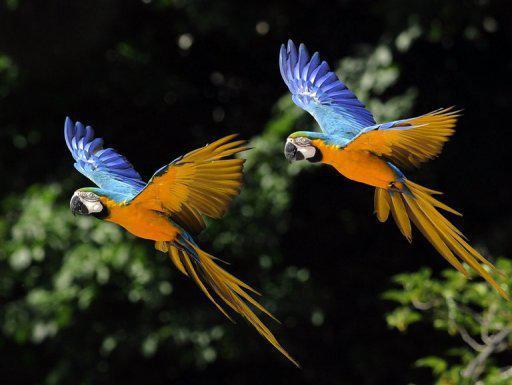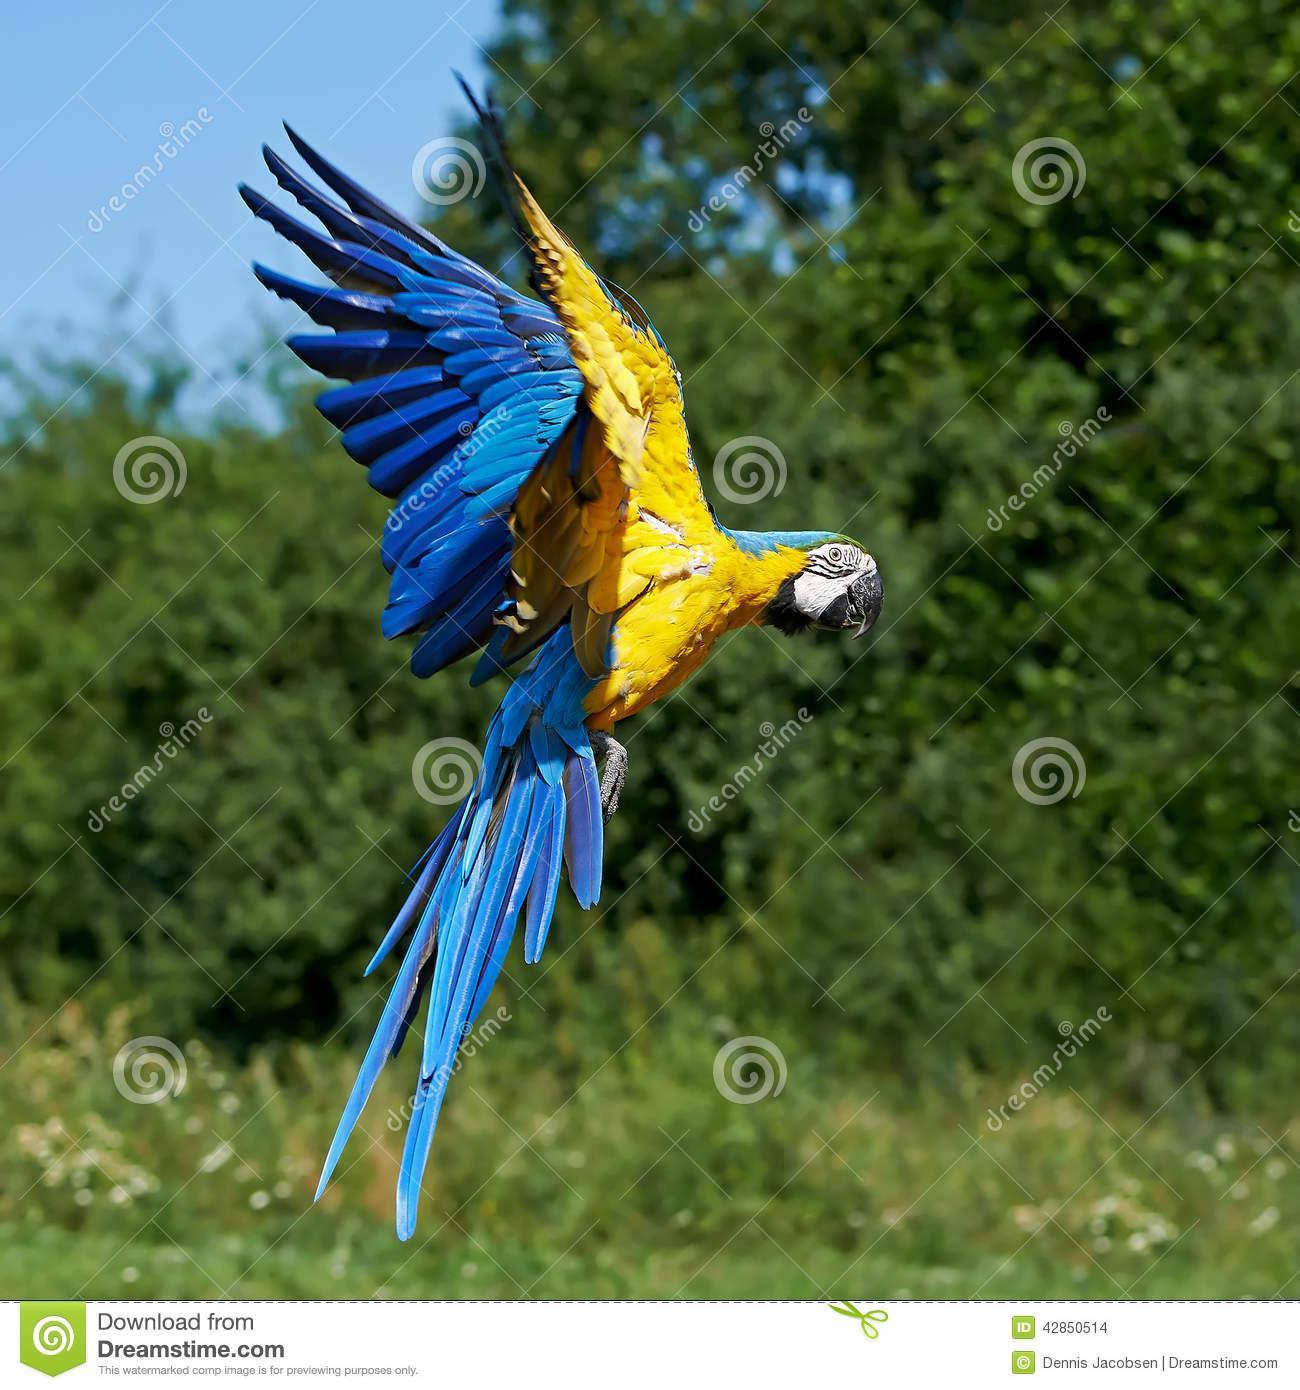The first image is the image on the left, the second image is the image on the right. Examine the images to the left and right. Is the description "All of the colorful birds are flying in the air." accurate? Answer yes or no. Yes. The first image is the image on the left, the second image is the image on the right. Assess this claim about the two images: "All birds have yellow and blue coloring and all birds are in flight.". Correct or not? Answer yes or no. Yes. 